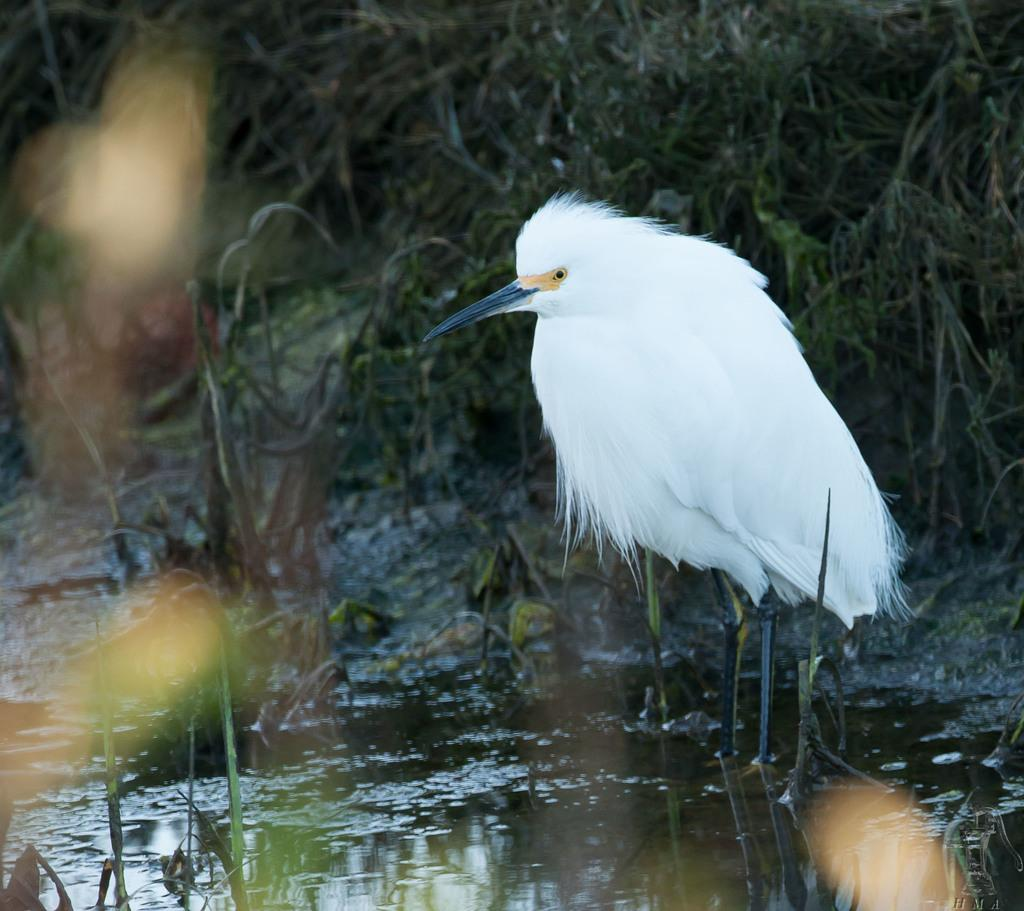What type of animal can be seen in the water on the right side of the image? There is a white color bird standing in the water on the right side of the image. What is present on the left side of the image? There are plants on the left side of the image. What can be seen in the background of the image? In the background, there are plants on the ground. Can you hear the bird crying in the image? There is no indication of sound in the image, so it cannot be determined if the bird is crying or not. 